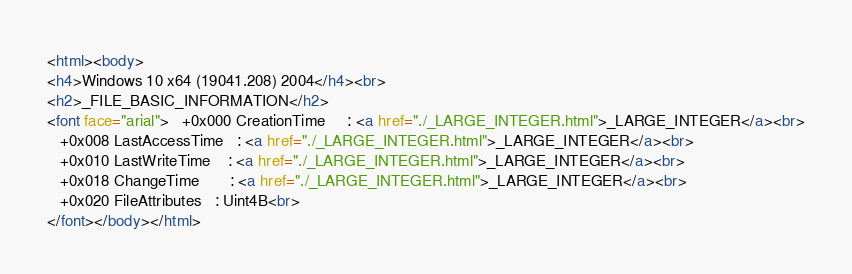<code> <loc_0><loc_0><loc_500><loc_500><_HTML_><html><body>
<h4>Windows 10 x64 (19041.208) 2004</h4><br>
<h2>_FILE_BASIC_INFORMATION</h2>
<font face="arial">   +0x000 CreationTime     : <a href="./_LARGE_INTEGER.html">_LARGE_INTEGER</a><br>
   +0x008 LastAccessTime   : <a href="./_LARGE_INTEGER.html">_LARGE_INTEGER</a><br>
   +0x010 LastWriteTime    : <a href="./_LARGE_INTEGER.html">_LARGE_INTEGER</a><br>
   +0x018 ChangeTime       : <a href="./_LARGE_INTEGER.html">_LARGE_INTEGER</a><br>
   +0x020 FileAttributes   : Uint4B<br>
</font></body></html></code> 